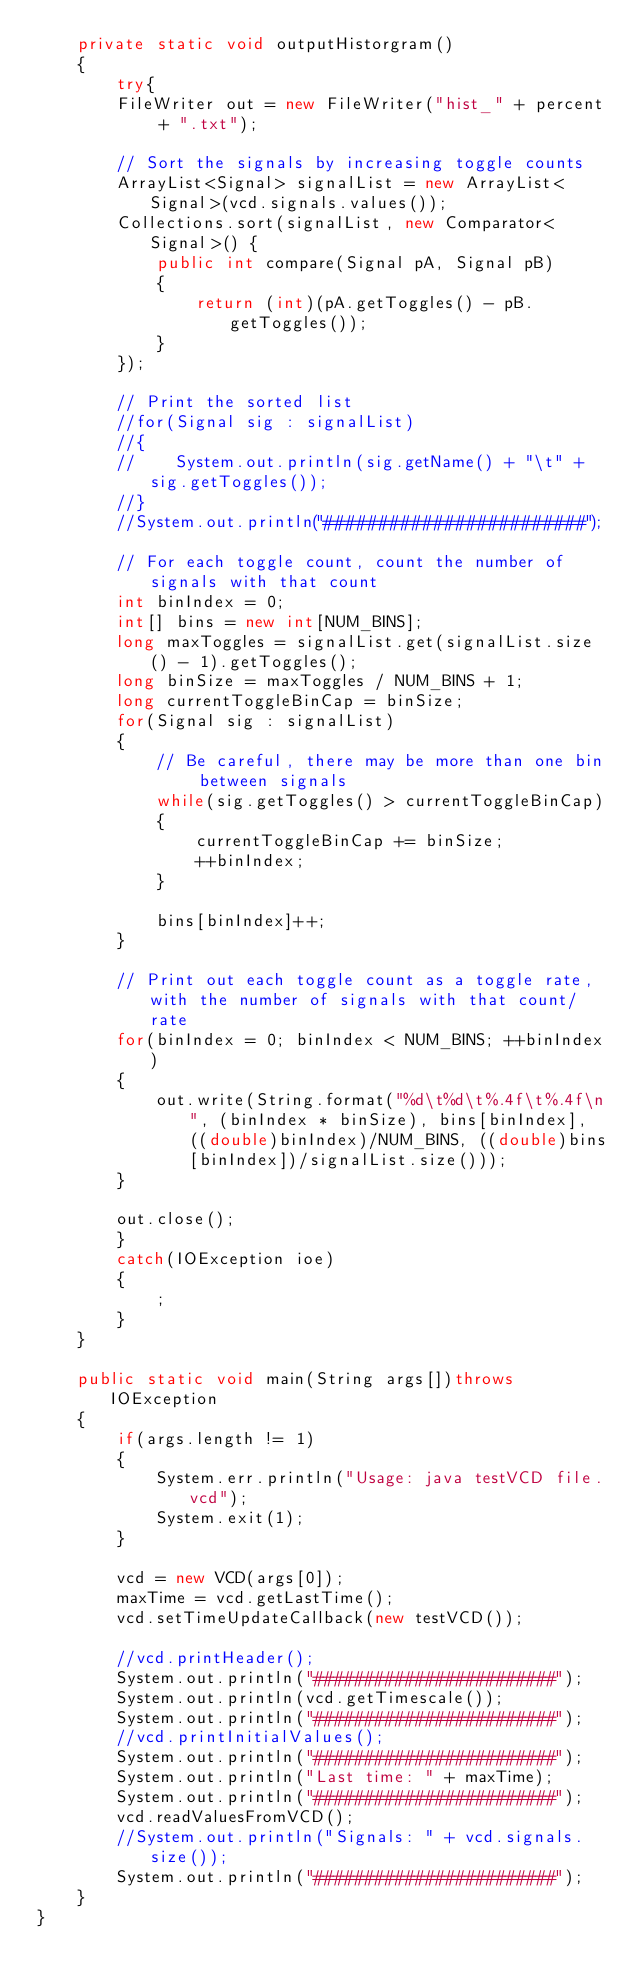<code> <loc_0><loc_0><loc_500><loc_500><_Java_>    private static void outputHistorgram()
    {
        try{
        FileWriter out = new FileWriter("hist_" + percent + ".txt");
        
        // Sort the signals by increasing toggle counts
        ArrayList<Signal> signalList = new ArrayList<Signal>(vcd.signals.values());
        Collections.sort(signalList, new Comparator<Signal>() {
            public int compare(Signal pA, Signal pB)
            {
                return (int)(pA.getToggles() - pB.getToggles());
            }
        });
        
        // Print the sorted list
        //for(Signal sig : signalList)
        //{
        //    System.out.println(sig.getName() + "\t" + sig.getToggles());
        //}
        //System.out.println("########################");
        
        // For each toggle count, count the number of signals with that count
        int binIndex = 0;
        int[] bins = new int[NUM_BINS];
        long maxToggles = signalList.get(signalList.size() - 1).getToggles();
        long binSize = maxToggles / NUM_BINS + 1;
        long currentToggleBinCap = binSize;
        for(Signal sig : signalList)
        {
            // Be careful, there may be more than one bin between signals
            while(sig.getToggles() > currentToggleBinCap)
            {
                currentToggleBinCap += binSize;
                ++binIndex;
            }
            
            bins[binIndex]++;
        }
        
        // Print out each toggle count as a toggle rate, with the number of signals with that count/rate
        for(binIndex = 0; binIndex < NUM_BINS; ++binIndex)
        {
            out.write(String.format("%d\t%d\t%.4f\t%.4f\n", (binIndex * binSize), bins[binIndex], ((double)binIndex)/NUM_BINS, ((double)bins[binIndex])/signalList.size()));
        }
        
        out.close();
        }
        catch(IOException ioe)
        {
            ;
        }
    }
    
    public static void main(String args[])throws IOException
    {
        if(args.length != 1)
        {
            System.err.println("Usage: java testVCD file.vcd");
            System.exit(1);
        }
        
        vcd = new VCD(args[0]);
        maxTime = vcd.getLastTime();
        vcd.setTimeUpdateCallback(new testVCD());
        
        //vcd.printHeader();
        System.out.println("########################");
        System.out.println(vcd.getTimescale());
        System.out.println("########################");
        //vcd.printInitialValues();
        System.out.println("########################");
        System.out.println("Last time: " + maxTime);
        System.out.println("########################");
        vcd.readValuesFromVCD();
        //System.out.println("Signals: " + vcd.signals.size());
        System.out.println("########################");
    }
}
</code> 